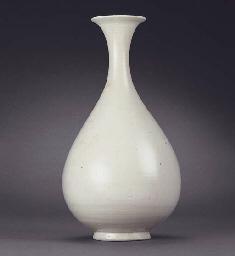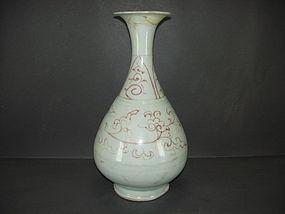The first image is the image on the left, the second image is the image on the right. Considering the images on both sides, is "Each vase has a round pair shaped base with a skinny neck and a fluted opening at the top." valid? Answer yes or no. Yes. The first image is the image on the left, the second image is the image on the right. Examine the images to the left and right. Is the description "One of the images shows a plain white vase." accurate? Answer yes or no. Yes. 